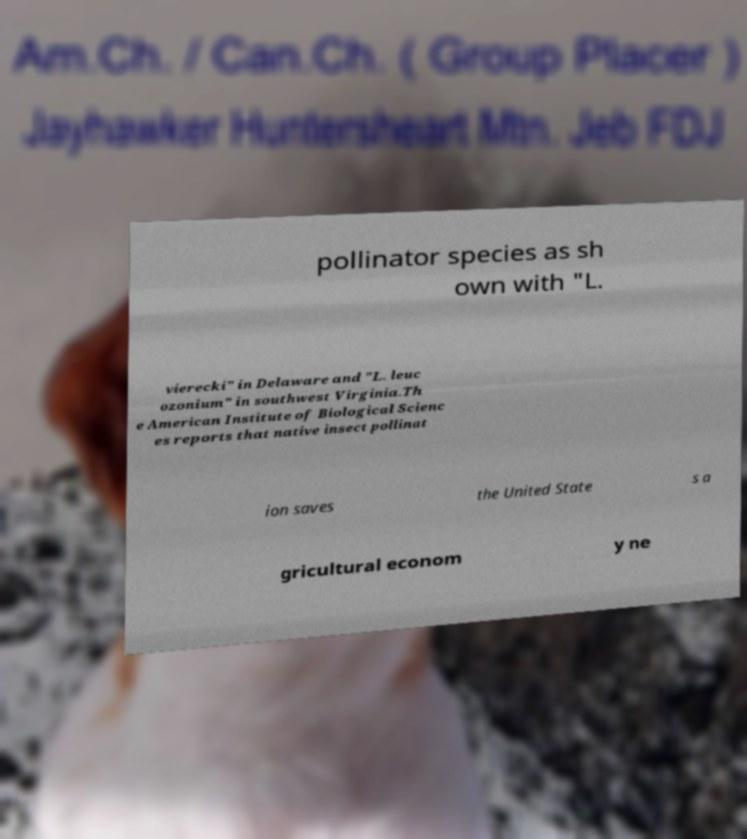What messages or text are displayed in this image? I need them in a readable, typed format. pollinator species as sh own with "L. vierecki" in Delaware and "L. leuc ozonium" in southwest Virginia.Th e American Institute of Biological Scienc es reports that native insect pollinat ion saves the United State s a gricultural econom y ne 